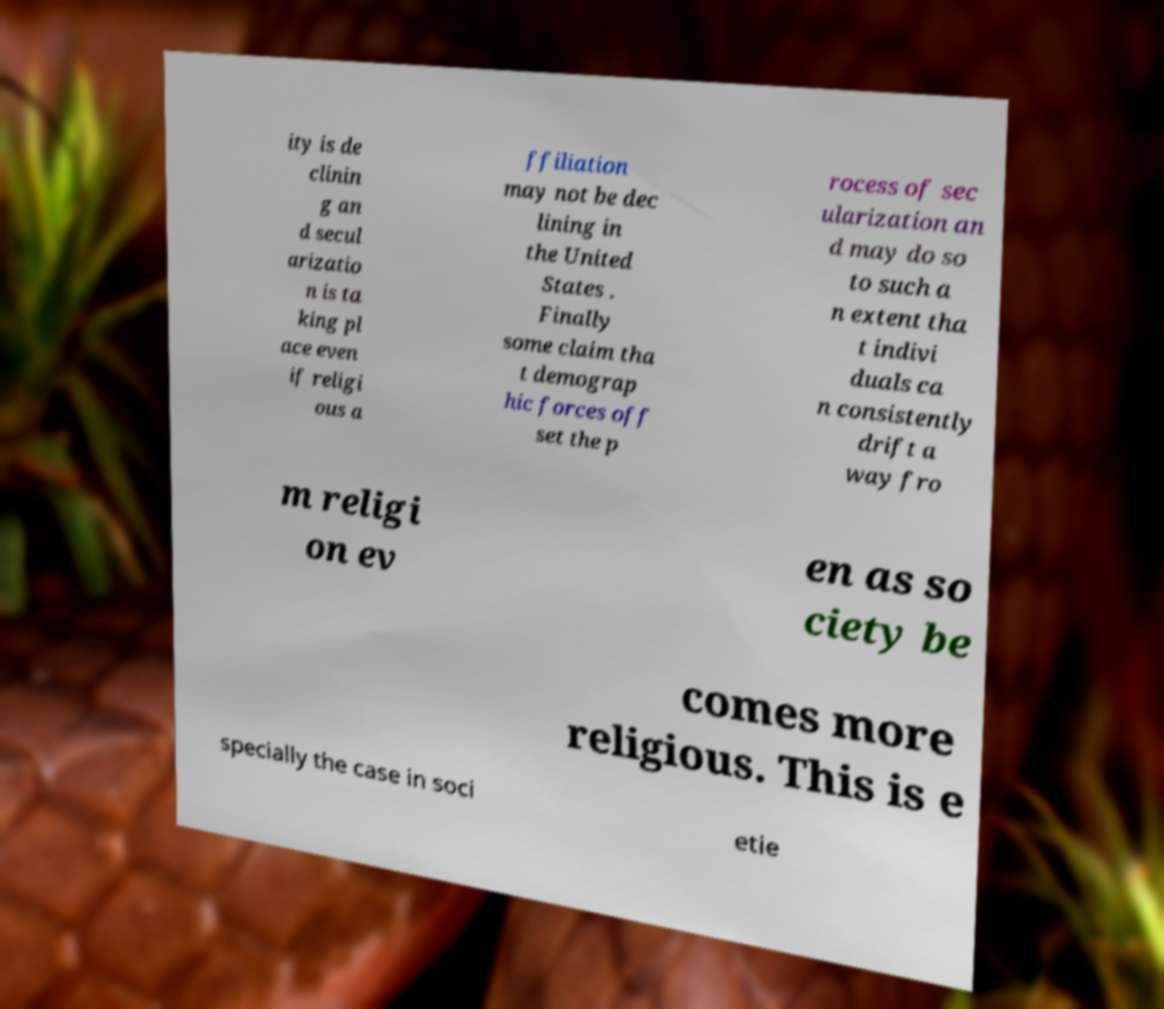Can you accurately transcribe the text from the provided image for me? ity is de clinin g an d secul arizatio n is ta king pl ace even if religi ous a ffiliation may not be dec lining in the United States . Finally some claim tha t demograp hic forces off set the p rocess of sec ularization an d may do so to such a n extent tha t indivi duals ca n consistently drift a way fro m religi on ev en as so ciety be comes more religious. This is e specially the case in soci etie 